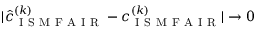Convert formula to latex. <formula><loc_0><loc_0><loc_500><loc_500>| \hat { c } _ { I S M F A I R } ^ { ( k ) } - c _ { I S M F A I R } ^ { ( k ) } | \to 0</formula> 